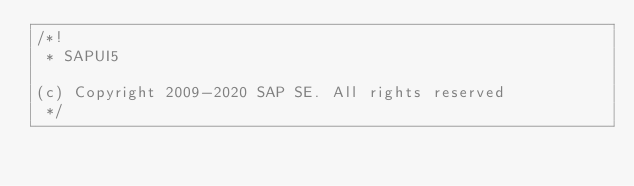<code> <loc_0><loc_0><loc_500><loc_500><_JavaScript_>/*!
 * SAPUI5

(c) Copyright 2009-2020 SAP SE. All rights reserved
 */</code> 